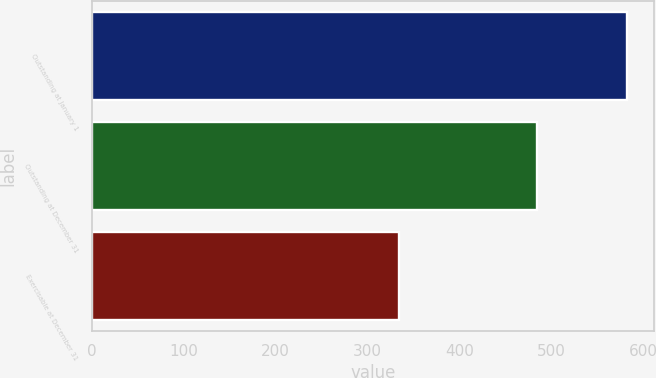<chart> <loc_0><loc_0><loc_500><loc_500><bar_chart><fcel>Outstanding at January 1<fcel>Outstanding at December 31<fcel>Exercisable at December 31<nl><fcel>583<fcel>485<fcel>334<nl></chart> 